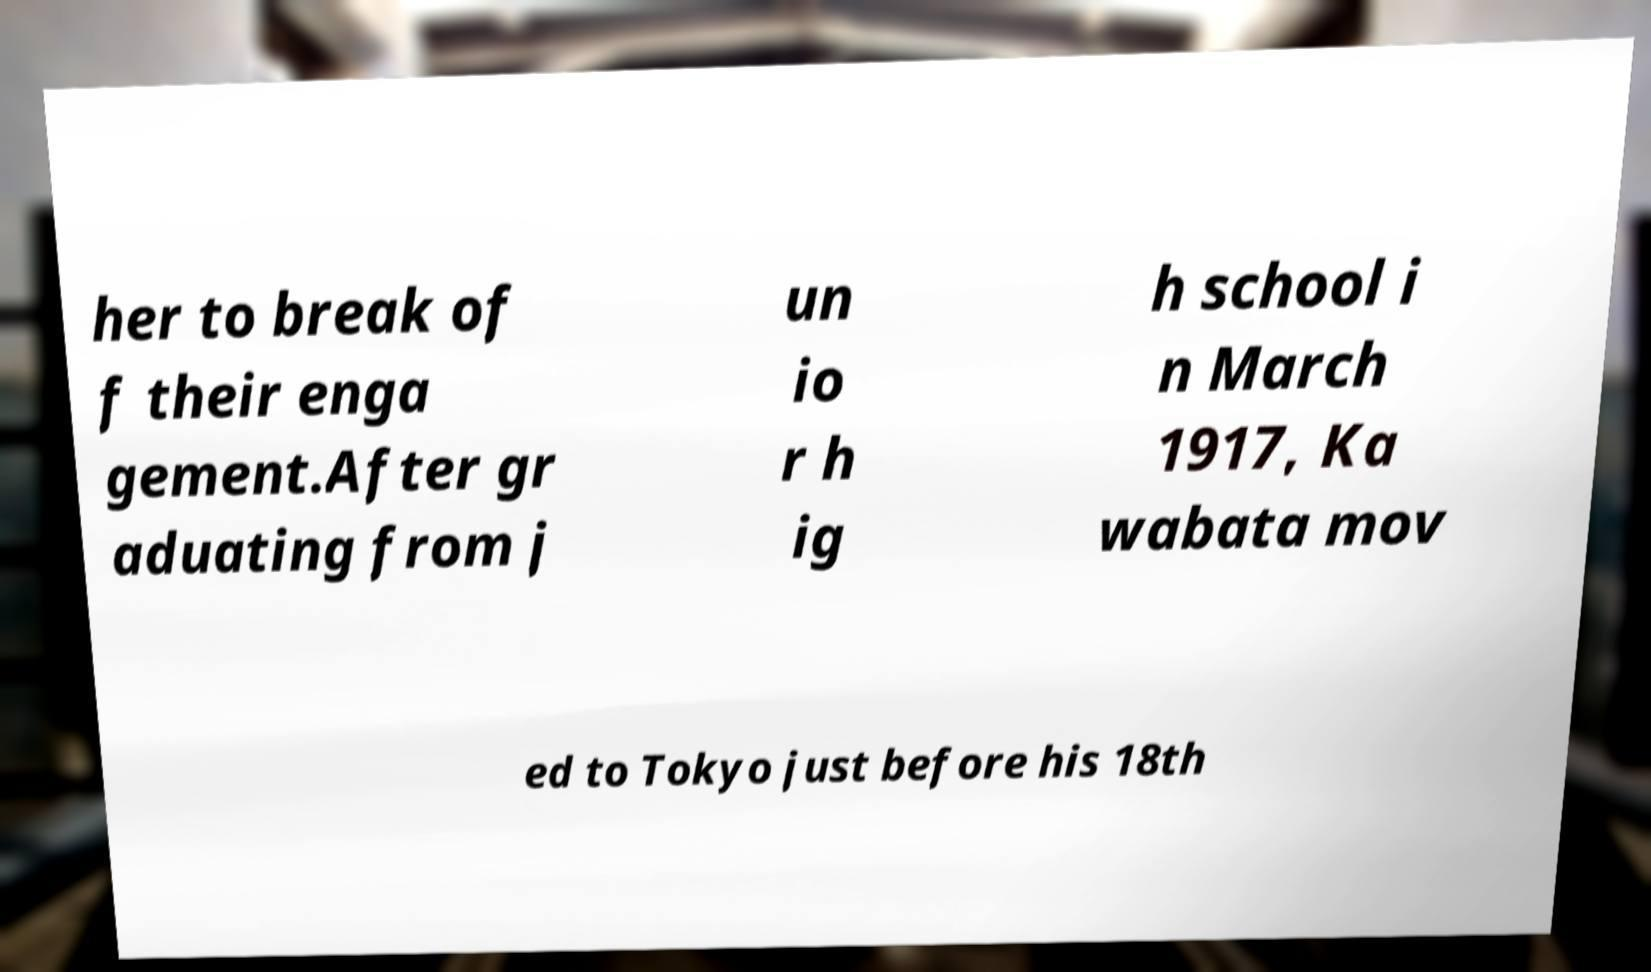Could you extract and type out the text from this image? her to break of f their enga gement.After gr aduating from j un io r h ig h school i n March 1917, Ka wabata mov ed to Tokyo just before his 18th 